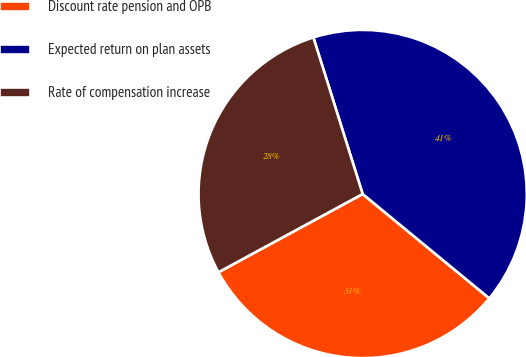Convert chart to OTSL. <chart><loc_0><loc_0><loc_500><loc_500><pie_chart><fcel>Discount rate pension and OPB<fcel>Expected return on plan assets<fcel>Rate of compensation increase<nl><fcel>31.12%<fcel>40.82%<fcel>28.06%<nl></chart> 